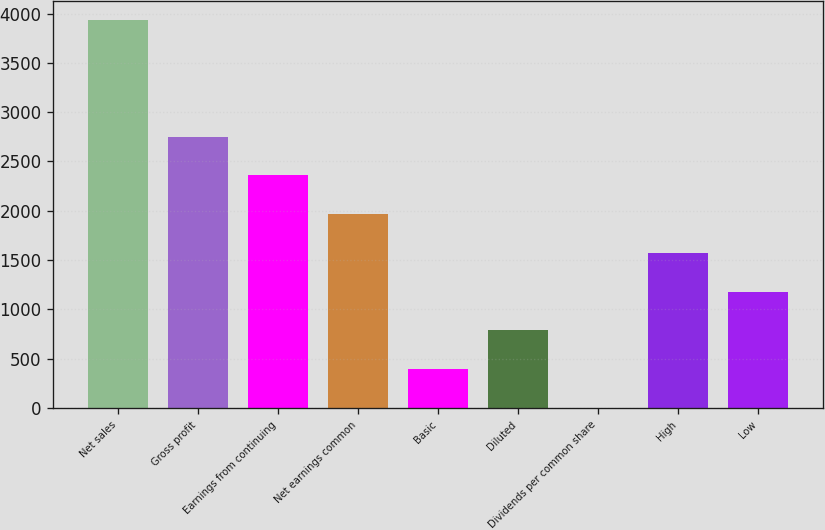Convert chart. <chart><loc_0><loc_0><loc_500><loc_500><bar_chart><fcel>Net sales<fcel>Gross profit<fcel>Earnings from continuing<fcel>Net earnings common<fcel>Basic<fcel>Diluted<fcel>Dividends per common share<fcel>High<fcel>Low<nl><fcel>3932<fcel>2752.52<fcel>2359.37<fcel>1966.22<fcel>393.62<fcel>786.77<fcel>0.47<fcel>1573.07<fcel>1179.92<nl></chart> 